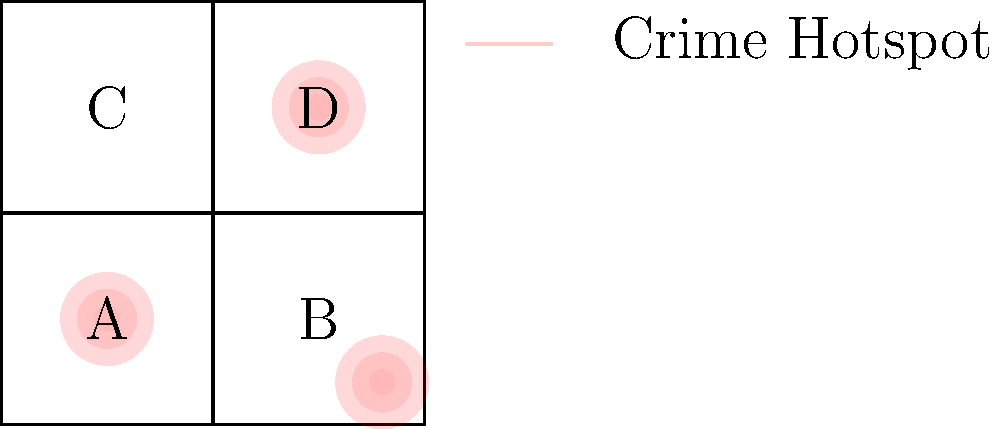Based on the heat map overlay on the precinct boundaries, which two precincts should be prioritized for increased patrol and resource allocation to address the most significant crime hotspots? To determine which two precincts should be prioritized, we need to analyze the heat map overlay on the precinct boundaries:

1. Identify the precincts:
   A: Top-left
   B: Top-right
   C: Bottom-left
   D: Bottom-right

2. Locate the crime hotspots:
   - There are three visible hotspots on the map.

3. Analyze the hotspots in relation to the precincts:
   - The largest and most intense hotspot is centered in precinct D.
   - The second largest hotspot is centered at the intersection of all four precincts, but appears to have the most coverage in precinct A.
   - The third hotspot is smaller and located in the lower right corner of precinct B.

4. Evaluate the impact on each precinct:
   - Precinct A: Contains a significant portion of one major hotspot.
   - Precinct B: Contains a smaller hotspot.
   - Precinct C: Minimal hotspot activity.
   - Precinct D: Contains the largest and most intense hotspot.

5. Prioritize based on hotspot intensity and coverage:
   - Precinct D has the most significant hotspot activity.
   - Precinct A has the second most significant hotspot activity.

Therefore, precincts D and A should be prioritized for increased patrol and resource allocation to address the most significant crime hotspots.
Answer: Precincts D and A 